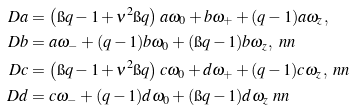Convert formula to latex. <formula><loc_0><loc_0><loc_500><loc_500>\ D a & = \left ( \i q - 1 + \nu ^ { 2 } \i q \right ) a \omega _ { 0 } + b \omega _ { + } + ( q - 1 ) a \omega _ { z } , \\ \ D b & = a \omega _ { - } + ( q - 1 ) b \omega _ { 0 } + ( \i q - 1 ) b \omega _ { z } , \ n n \\ \ D c & = \left ( \i q - 1 + \nu ^ { 2 } \i q \right ) c \omega _ { 0 } + d \omega _ { + } + ( q - 1 ) c \omega _ { z } , \ n n \\ \ D d & = c \omega _ { - } + ( q - 1 ) d \omega _ { 0 } + ( \i q - 1 ) d \omega _ { z } \ n n</formula> 